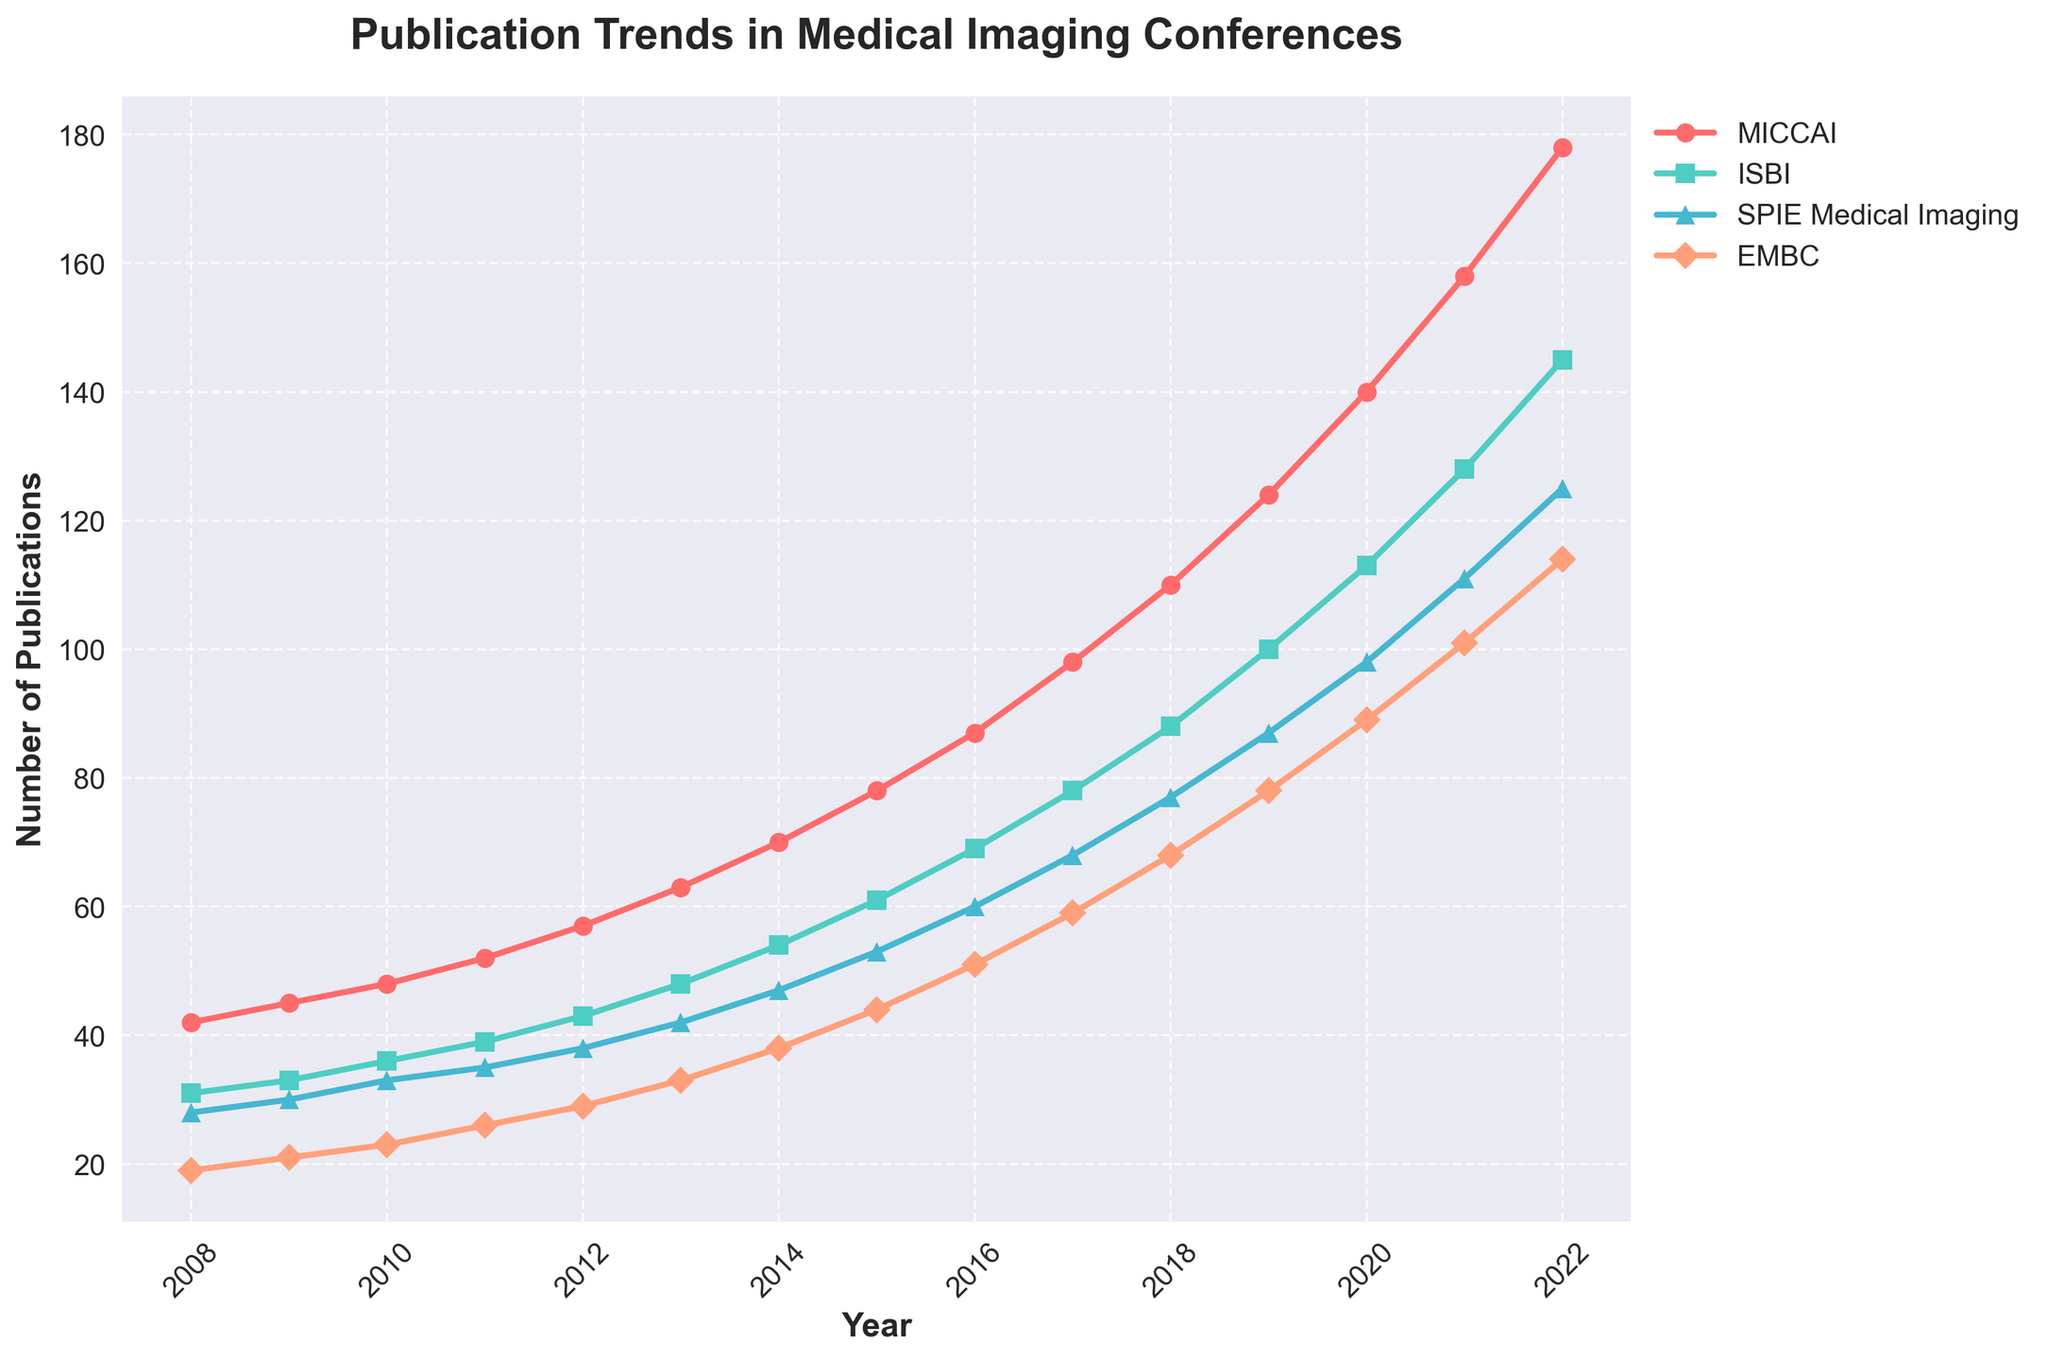How does the number of publications in MICCAI compare between 2012 and 2015? Look at the 'MICCAI' curve and find the values for the years 2012 and 2015. In 2012, the number of publications was 57, and in 2015, it was 78. Subtracting 57 from 78 gives the difference.
Answer: 21 Which conference had the least number of publications in 2022? Find the values for all conferences in 2022. MICCAI had 178, ISBI had 145, SPIE Medical Imaging had 125, and EMBC had 114. The smallest number is 114.
Answer: EMBC What is the total number of publications across all conferences in 2010? Add up the values for all conferences in 2010: MICCAI had 48, ISBI had 36, SPIE Medical Imaging had 33, and EMBC had 23. Summing them, 48 + 36 + 33 + 23 = 140.
Answer: 140 How did the publication numbers for ISBI and SPIE Medical Imaging in 2019 compare? Look at the values for ISBI and SPIE Medical Imaging in 2019. ISBI had 100 publications, while SPIE Medical Imaging had 87. This shows that ISBI had more publications.
Answer: ISBI had 13 more In which year did MICCAI first surpass 100 publications? Find the first year where the MICCAI line crosses the 100 mark. MICCAI had 110 publications in 2018, and in 2017 it had 98.
Answer: 2018 Which conference showed the most growth from 2008 to 2022? Calculate the difference in publications between 2022 and 2008 for each conference. MICCAI: 178 - 42 = 136, ISBI: 145 - 31 = 114, SPIE Medical Imaging: 125 - 28 = 97, EMBC: 114 - 19 = 95. The largest growth is for MICCAI.
Answer: MICCAI What was the average number of publications for SPIE Medical Imaging from 2016 to 2018? Find the values for SPIE Medical Imaging in 2016, 2017, and 2018. They are 60, 68, and 77 respectively. Sum them: 60 + 68 + 77 = 205. Then, average: 205 / 3 = 68.33.
Answer: 68.33 Compare the publication trends of EMBC and ISBI over the last 15 years. Check the increasing trends for both conferences from 2008 to 2022. EMBC increased from 19 to 114, and ISBI increased from 31 to 145. Both conferences show an upward trend, but ISBI's growth is greater.
Answer: ISBI had greater growth What's the difference between the number of publications in MICCAI and ISBI in 2020? In 2020, MICCAI had 140 publications, and ISBI had 113. Subtract ISBI's number from MICCAI's number: 140 - 113 = 27.
Answer: 27 